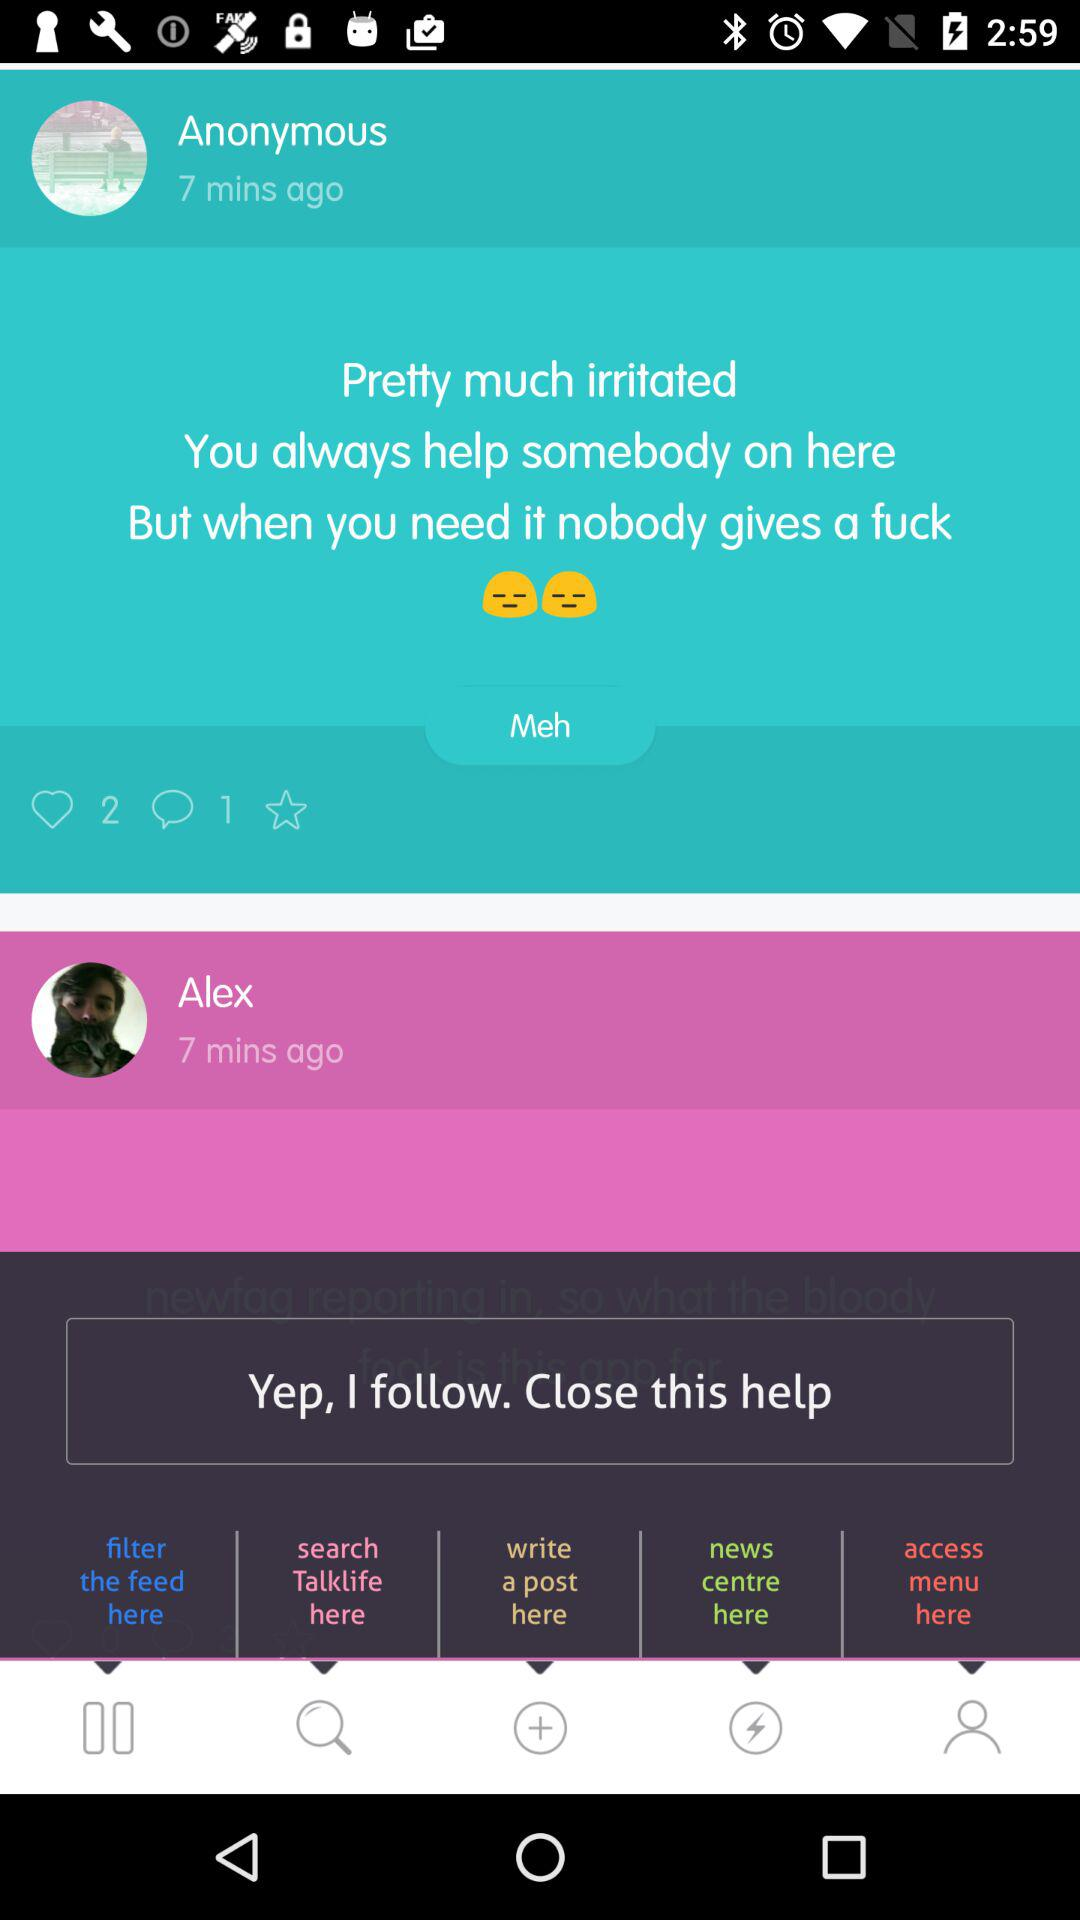How many more times did Anonymous post than Alex?
Answer the question using a single word or phrase. 1 